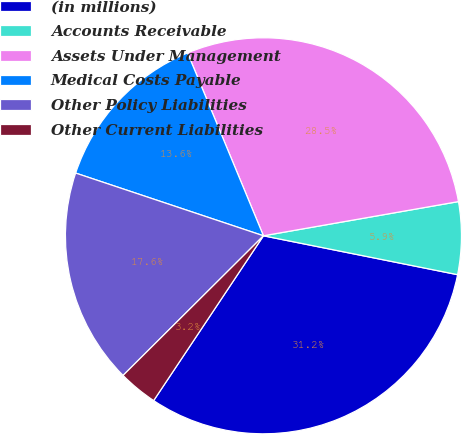Convert chart to OTSL. <chart><loc_0><loc_0><loc_500><loc_500><pie_chart><fcel>(in millions)<fcel>Accounts Receivable<fcel>Assets Under Management<fcel>Medical Costs Payable<fcel>Other Policy Liabilities<fcel>Other Current Liabilities<nl><fcel>31.21%<fcel>5.91%<fcel>28.5%<fcel>13.61%<fcel>17.59%<fcel>3.19%<nl></chart> 